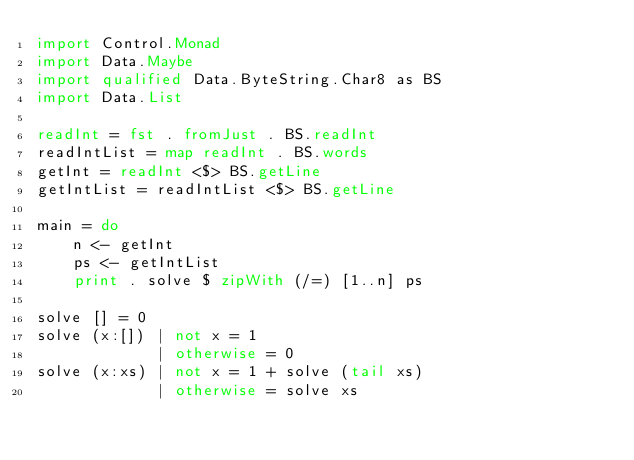<code> <loc_0><loc_0><loc_500><loc_500><_Haskell_>import Control.Monad
import Data.Maybe
import qualified Data.ByteString.Char8 as BS
import Data.List

readInt = fst . fromJust . BS.readInt
readIntList = map readInt . BS.words
getInt = readInt <$> BS.getLine
getIntList = readIntList <$> BS.getLine

main = do
    n <- getInt
    ps <- getIntList
    print . solve $ zipWith (/=) [1..n] ps

solve [] = 0
solve (x:[]) | not x = 1
             | otherwise = 0
solve (x:xs) | not x = 1 + solve (tail xs)
             | otherwise = solve xs</code> 